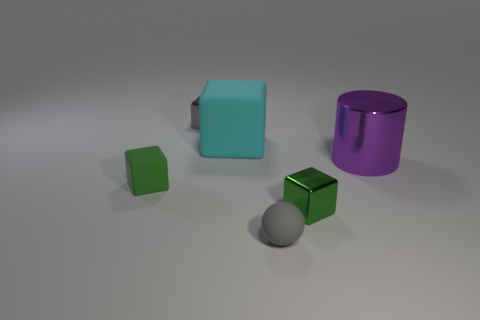Subtract all small blocks. How many blocks are left? 1 Add 1 large red spheres. How many objects exist? 7 Subtract all blocks. How many objects are left? 2 Subtract all green cylinders. How many green cubes are left? 2 Subtract 4 blocks. How many blocks are left? 0 Subtract all cyan cubes. How many cubes are left? 3 Subtract all gray cubes. Subtract all purple cylinders. How many cubes are left? 3 Subtract all gray cubes. Subtract all large brown rubber cylinders. How many objects are left? 5 Add 3 green things. How many green things are left? 5 Add 4 green metallic blocks. How many green metallic blocks exist? 5 